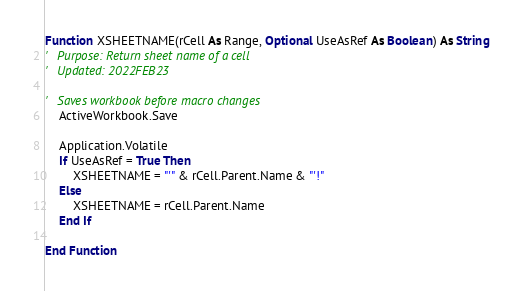<code> <loc_0><loc_0><loc_500><loc_500><_VisualBasic_>Function XSHEETNAME(rCell As Range, Optional UseAsRef As Boolean) As String
'   Purpose: Return sheet name of a cell
'   Updated: 2022FEB23

'   Saves workbook before macro changes
    ActiveWorkbook.Save
    
    Application.Volatile
    If UseAsRef = True Then
        XSHEETNAME = "'" & rCell.Parent.Name & "'!"
    Else
        XSHEETNAME = rCell.Parent.Name
    End If

End Function

</code> 